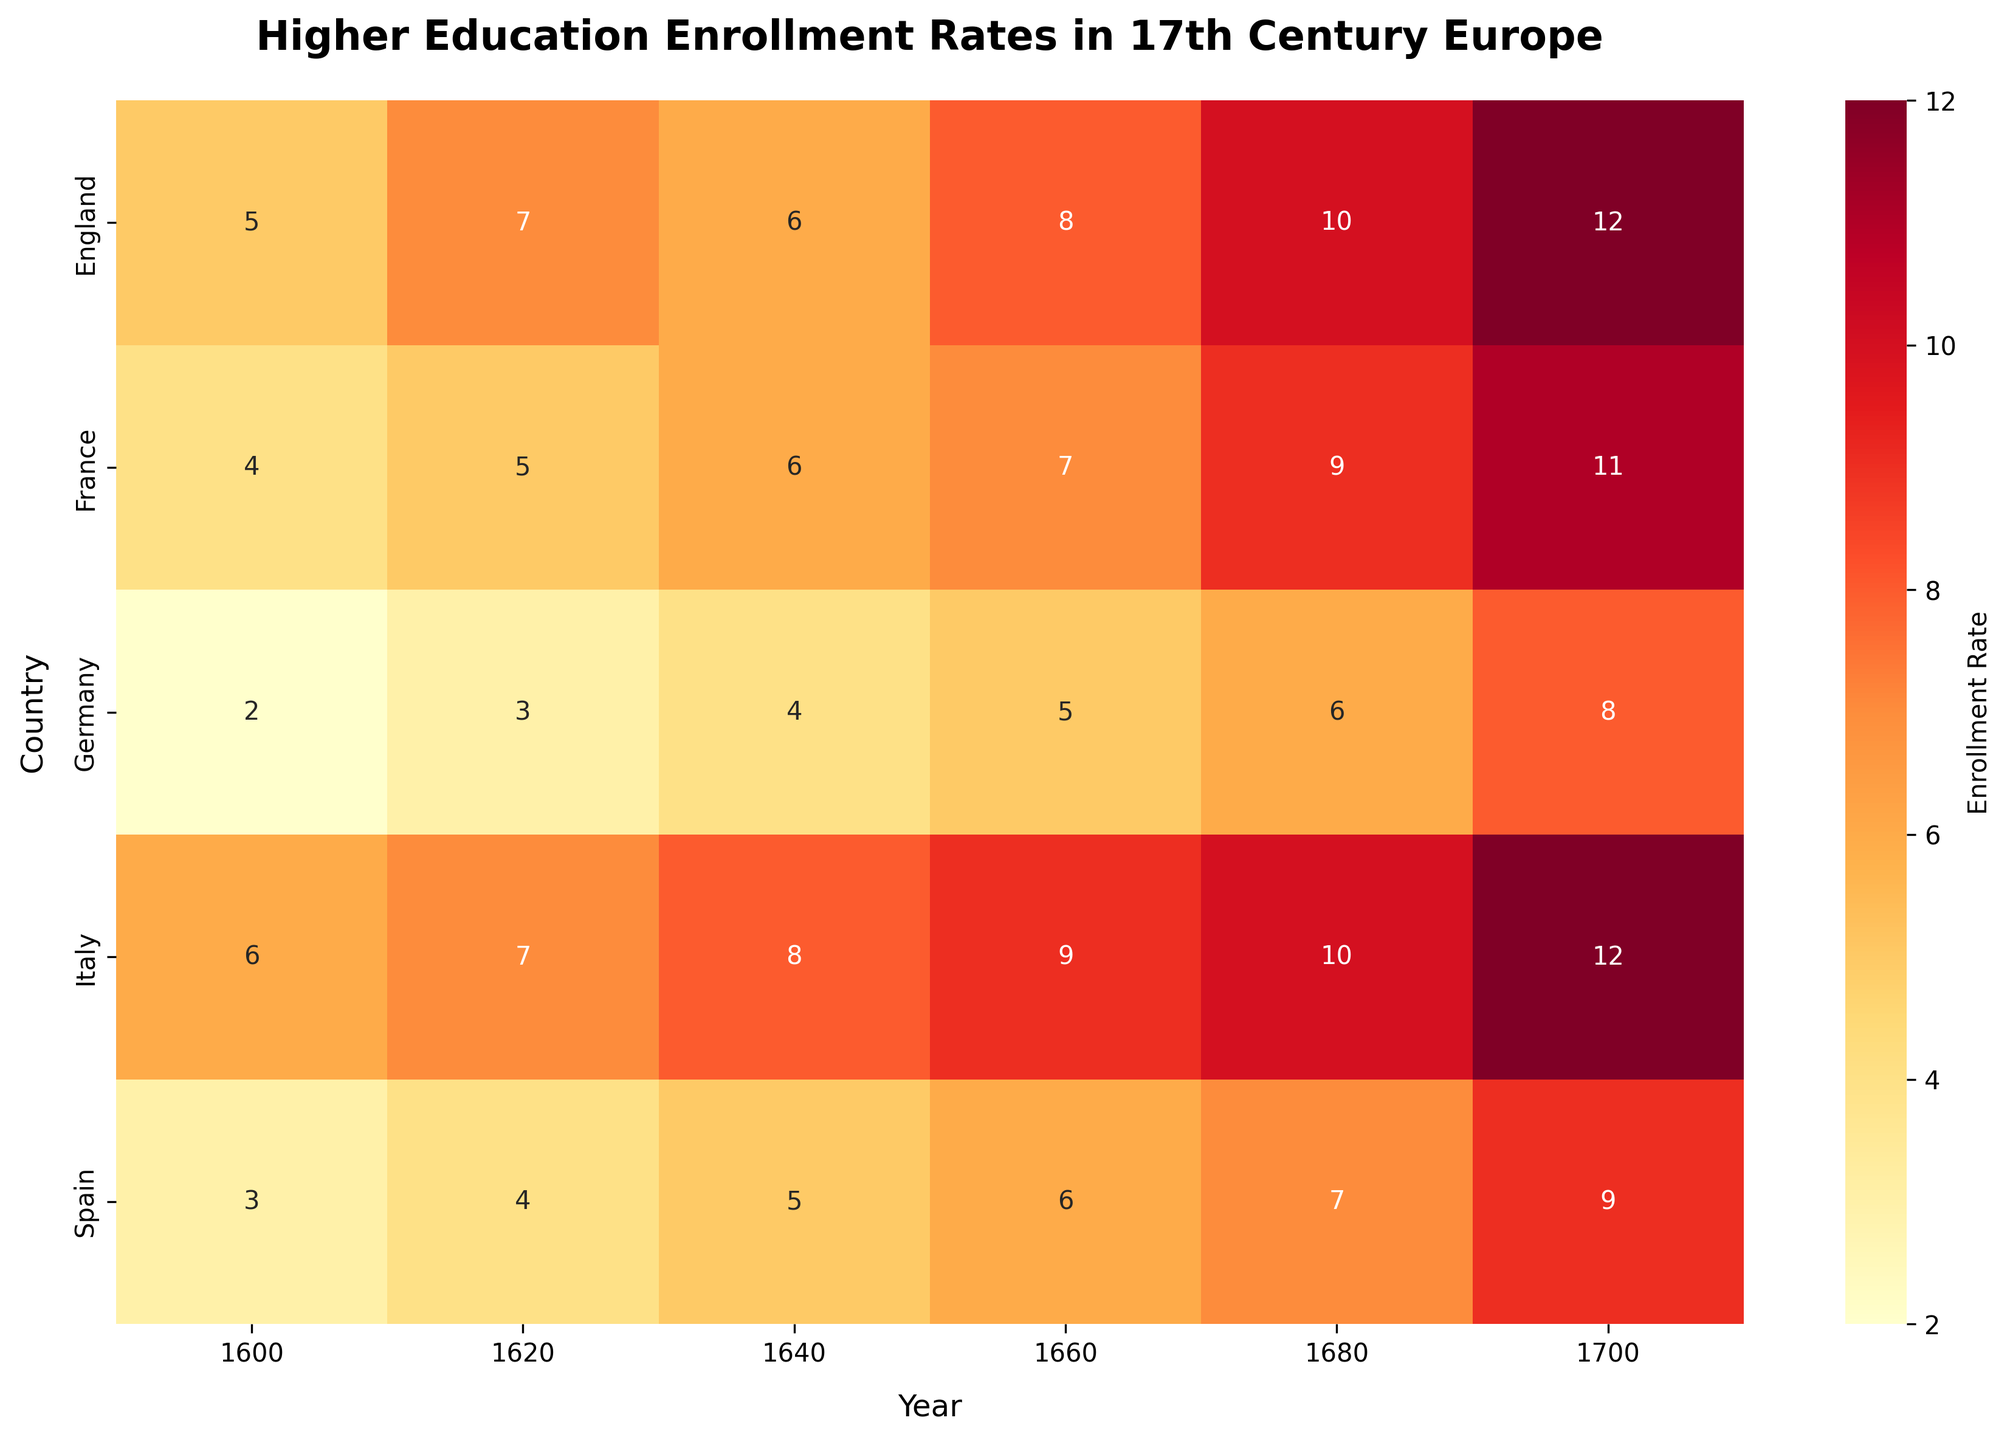How many countries are represented in the heatmap? By counting the number of rows in the heatmap, we can determine that the heatmap covers 5 countries: England, France, Germany, Italy, and Spain.
Answer: 5 Which country had the highest enrollment rate in 1600? Look at the first column (1600) in the heatmap and find the highest value among the countries listed. Italy has an enrollment rate of 6, which is the highest.
Answer: Italy What is the average enrollment rate for France across all years? Add the enrollment rates for France (4, 5, 6, 7, 9, 11) and divide by the number of years (6). The sum is 42, and the average is 42/6 = 7.
Answer: 7 Which year shows the highest overall enrollment rate? Examine each column to find the highest value in the heatmap. The year 1700 has the highest values compared to other years, noticeable by looking at the rightmost column: England (12), France (11), Germany (8), Italy (12), and Spain (9).
Answer: 1700 How much did England's enrollment rate increase from 1600 to 1700? Subtract England's enrollment rate in 1600 (5) from its rate in 1700 (12). The increase is 12 - 5 = 7.
Answer: 7 Which country had the most consistent increase in enrollment rates over the years? By examining the values across the rows for each country, we can see that France consistently increases its enrollment rate by 1 or 2 every 20 years.
Answer: France In which year did Spain surpass Germany in enrollment rates? Compare the values of Spain and Germany for each year until you find Spain's rate exceeding Germany's rate. Spain surpassed Germany in 1680, with Spain at 7 and Germany at 6.
Answer: 1680 Which country experienced the highest jump in enrollment rate between two consecutive years? Calculate the difference between enrollment rates for consecutive years for each country. Italy shows a jump from 1640 (8) to 1660 (9), but the highest jump is in Germany from 1680 (6) to 1700 (8), which is an increase of 2.
Answer: Germany What is the total enrollment rate for all countries in the year 1680? Add the enrollment rates for 1680 across all countries: England (10), France (9), Germany (6), Italy (10), and Spain (7). The sum is 10 + 9 + 6 + 10 + 7 = 42.
Answer: 42 